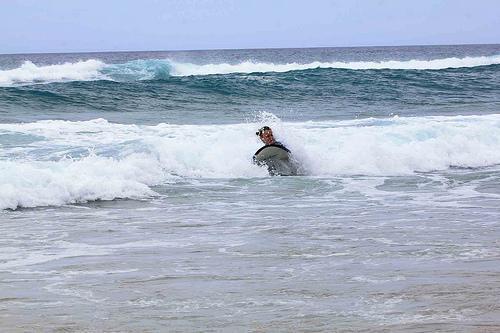How many people are in the picture?
Give a very brief answer. 1. 